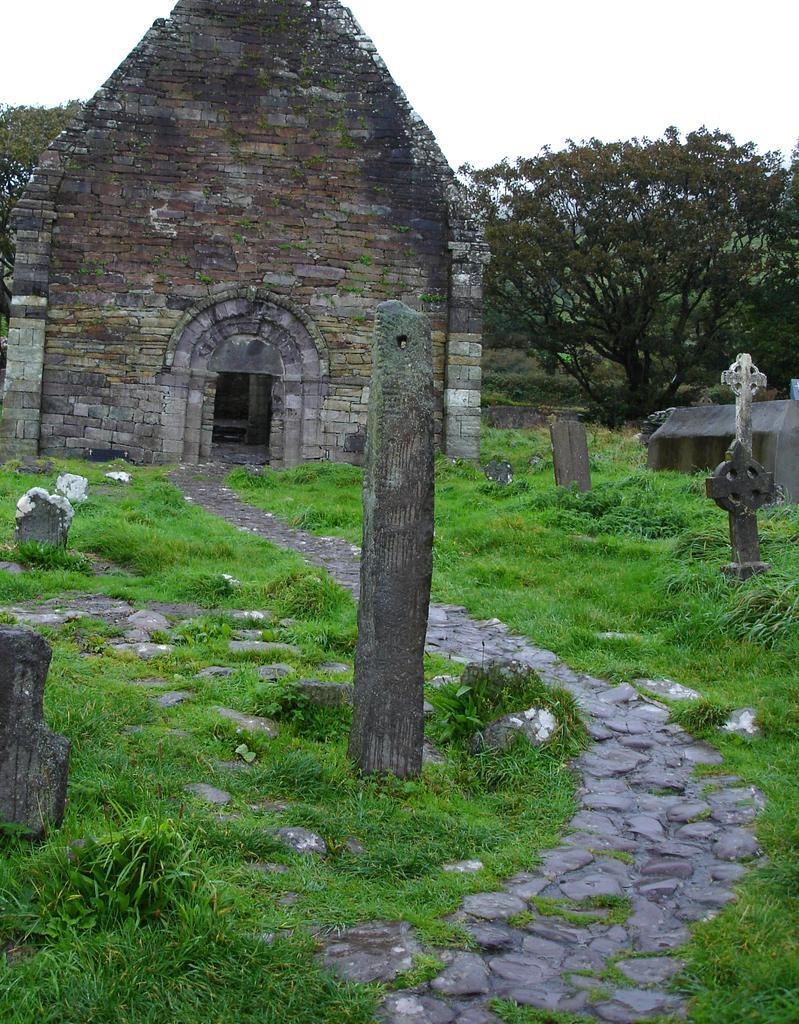Please provide a concise description of this image. In this picture we can observe a stone wall. There is a pole. We can observe some grass and stones here. In the background there are trees and a sky. 